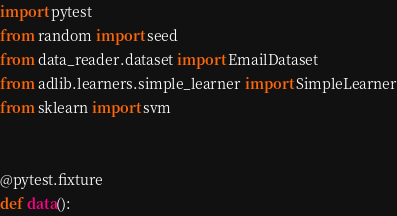<code> <loc_0><loc_0><loc_500><loc_500><_Python_>import pytest
from random import seed
from data_reader.dataset import EmailDataset
from adlib.learners.simple_learner import SimpleLearner
from sklearn import svm


@pytest.fixture
def data():</code> 